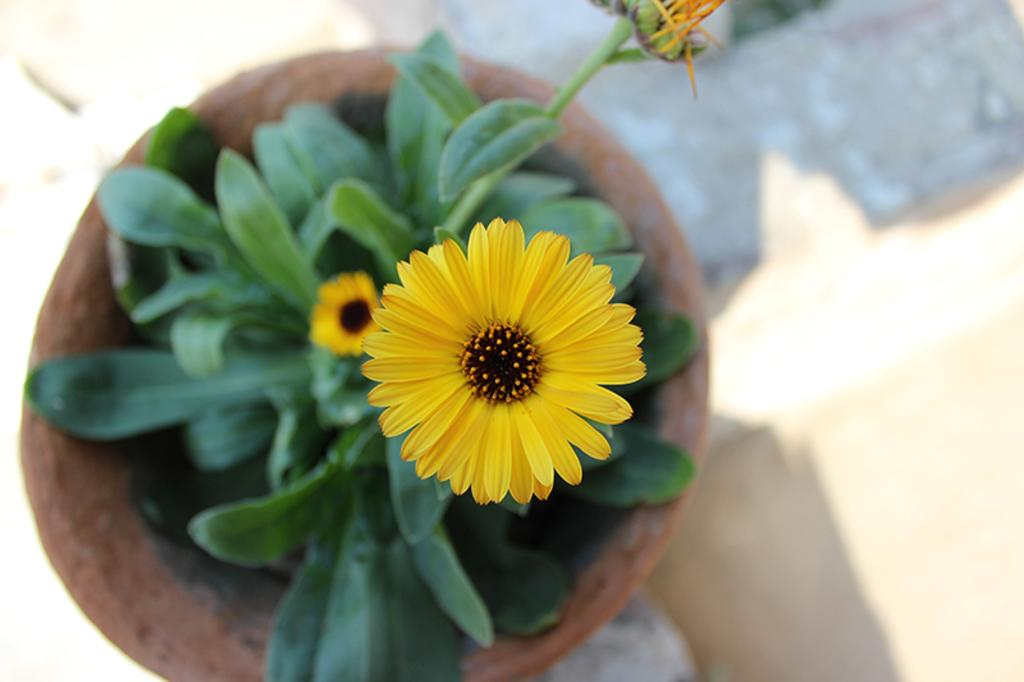What object is present in the image that holds a plant? There is a plant pot in the image that holds a plant. What is growing inside the plant pot? The plant pot contains a plant. How many flowers are on the plant in the image? The plant has two flowers. What can be seen beneath the plant pot in the image? The ground is visible in the image. What type of instrument is being played by the plant in the image? There is no instrument being played by the plant in the image, as plants do not have the ability to play musical instruments. 